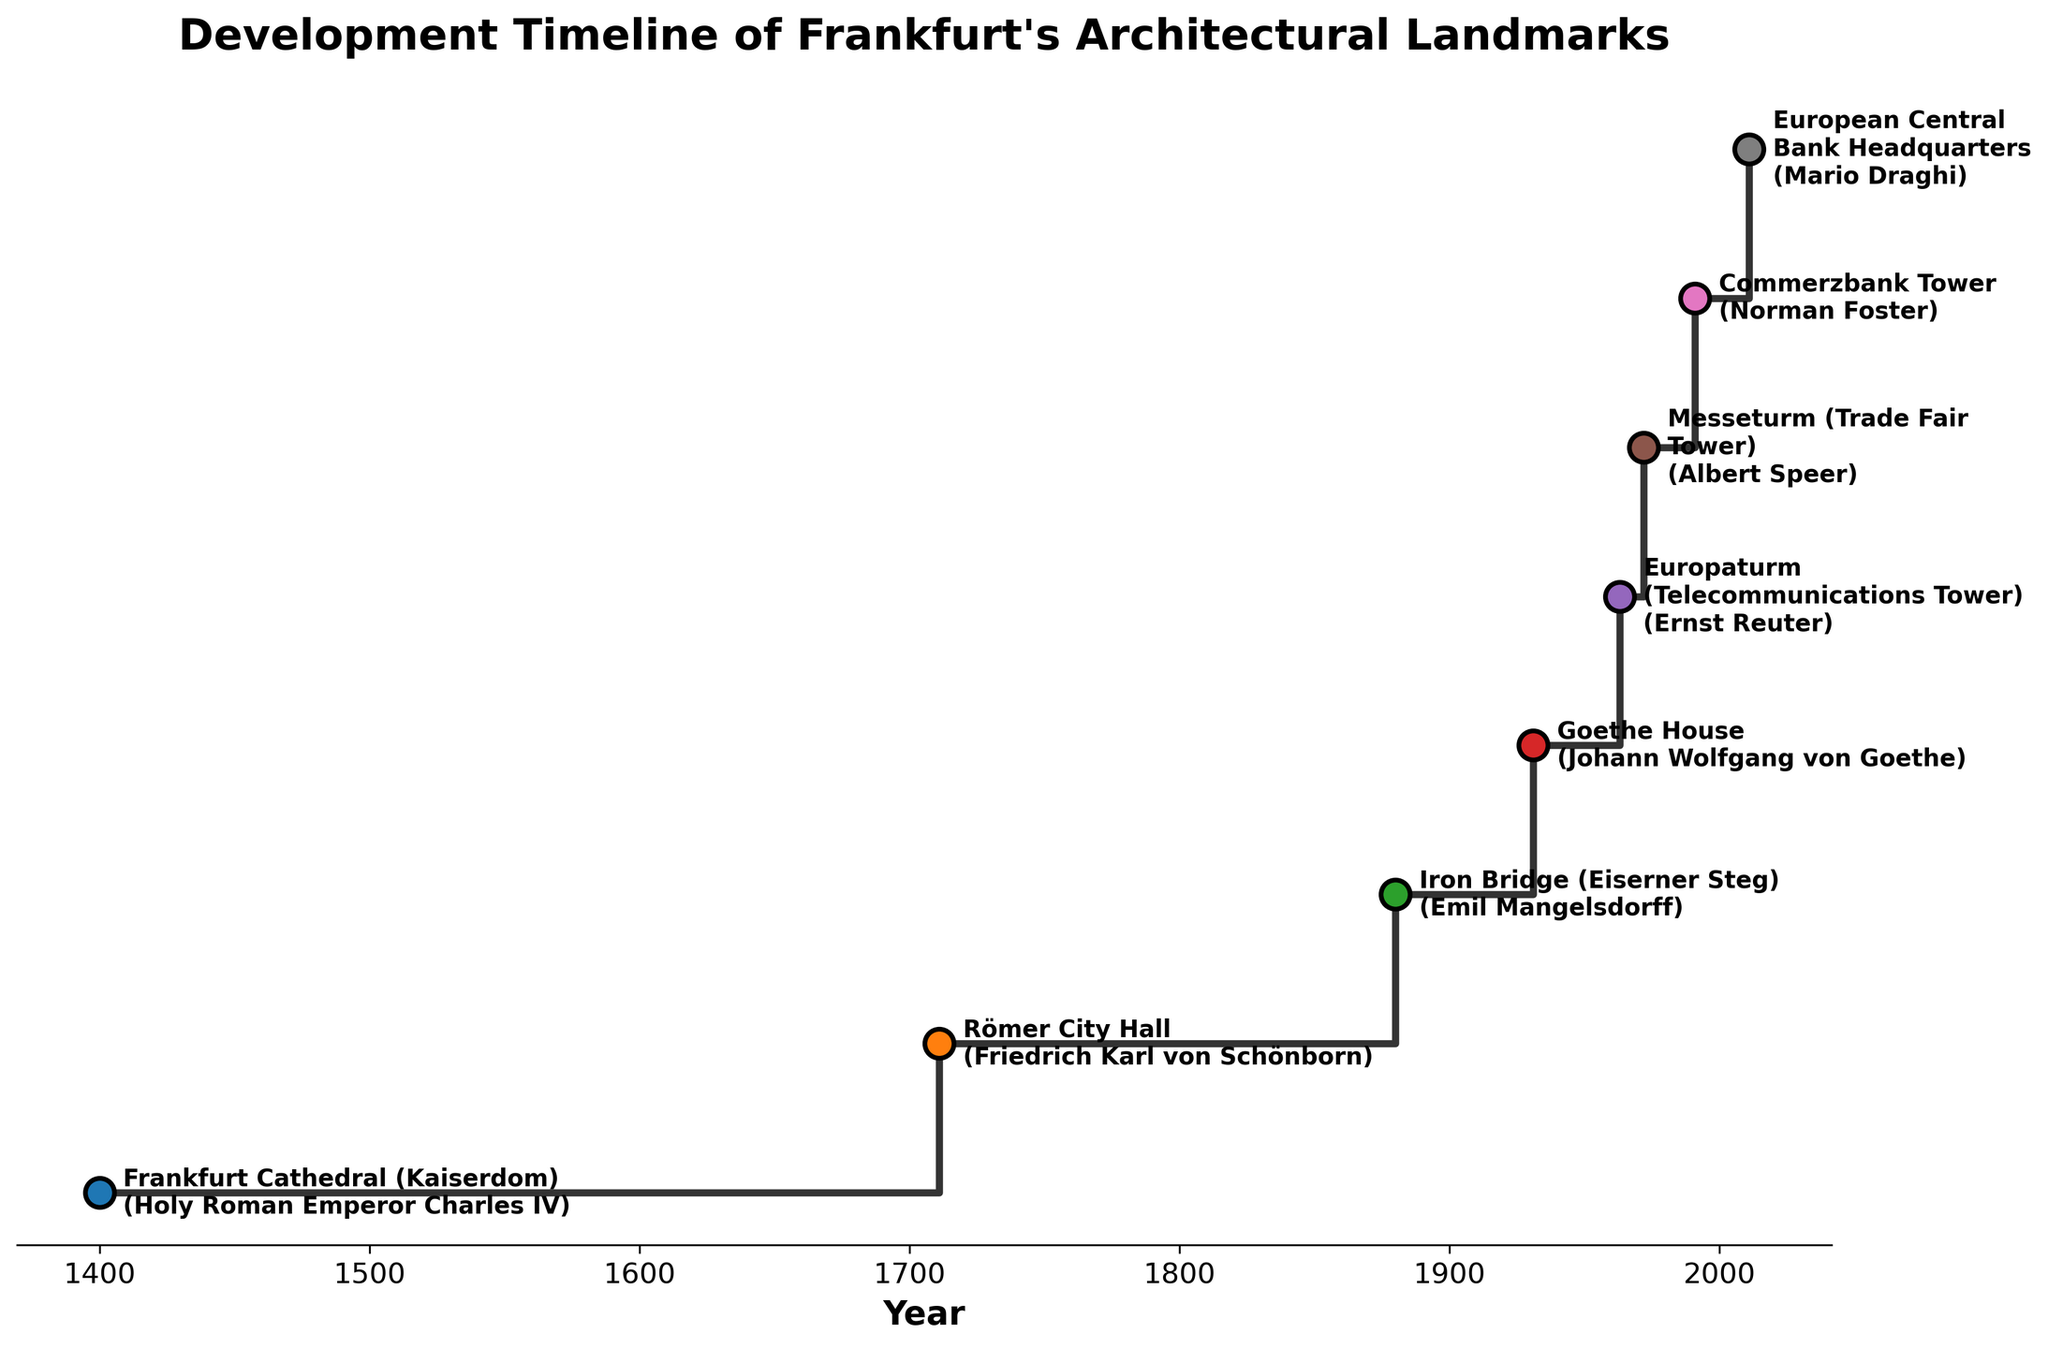Which landmark was built in the earliest year? By looking at the leftmost data point, we see it corresponds to the Frankfurt Cathedral, dated 1400.
Answer: Frankfurt Cathedral (Kaiserdom) What is the title of the figure? The title is displayed prominently at the top of the figure.
Answer: Development Timeline of Frankfurt's Architectural Landmarks How many landmarks were developed after 1900? Counting the data points plotted after the year 1900: Europaturm (1963), Messeturm (1972), Commerzbank Tower (1991), and European Central Bank Headquarters (2011).
Answer: 4 Which influential figure is associated with the Römer City Hall? Römer City Hall is labeled and its associated influential figure is noted next to it.
Answer: Friedrich Karl von Schönborn Which landmarks were developed between 1800 and 1900? Identifying data points within the given years on the x-axis reveals the Iron Bridge (1880).
Answer: Iron Bridge (Eiserner Steg) How many years apart were the construction of the Römer City Hall and Commerzbank Tower? Römer City Hall was developed in 1711 and the Commerzbank Tower in 1991. Calculating the difference: 1991 - 1711 = 280 years.
Answer: 280 years Which landmark is associated with Johann Wolfgang von Goethe? The annotation next to the landmark labeled as Goethe House shows Johann Wolfgang von Goethe as the associated figure.
Answer: Goethe House How many architectural landmarks are represented in the stair plot? Count the total number of data points plotted on the figure. There are 8 distinct data points.
Answer: 8 Which landmark has the most recently associated influential figure displayed? The rightmost data point corresponds to the most recent year, which is 2011, for the European Central Bank Headquarters, associated with Mario Draghi.
Answer: European Central Bank Headquarters Which two landmarks are closest in their year of development? Identifying the two data points with the smallest gap between their years: Europaturm (1963) and Messeturm (1972). The gap is 1972 - 1963 = 9 years.
Answer: Europaturm and Messeturm 